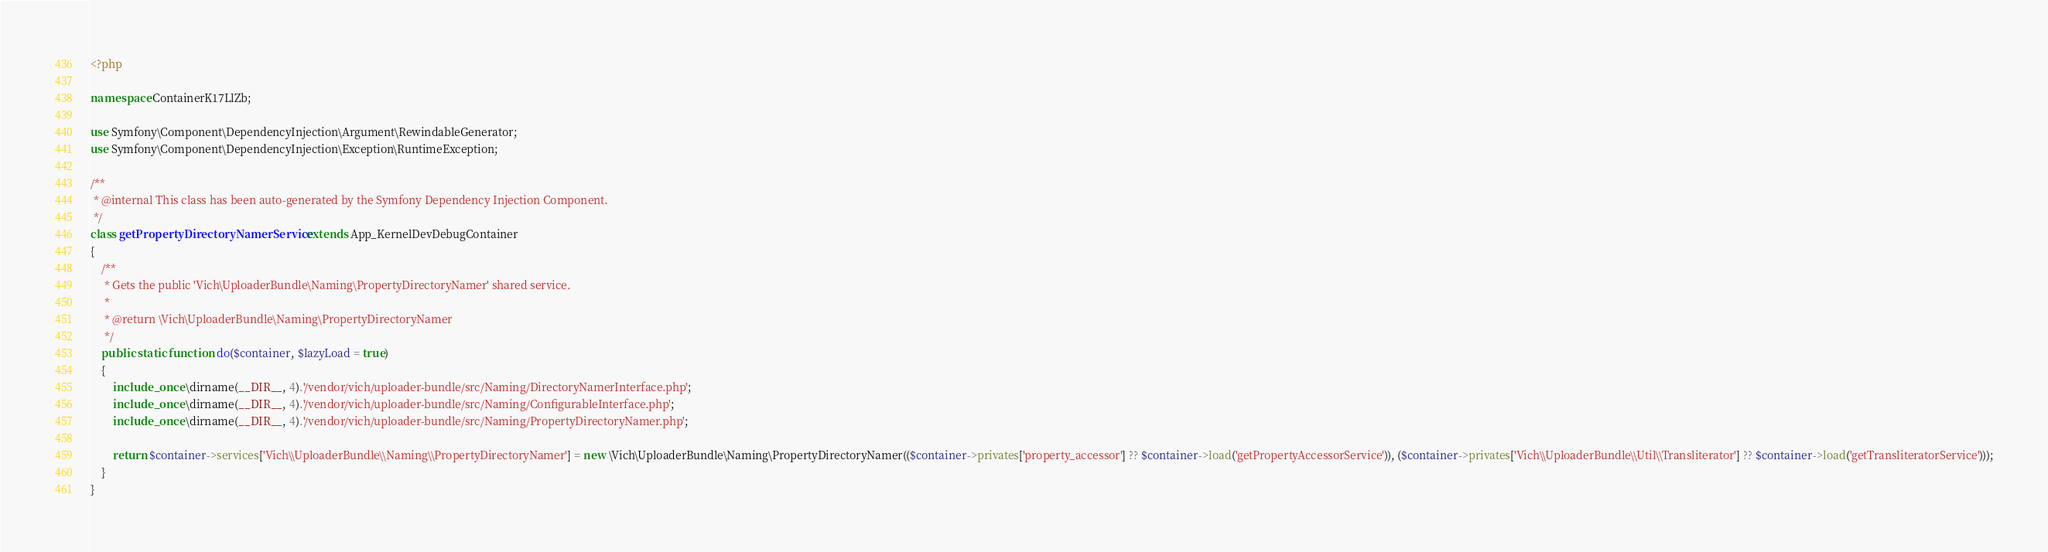<code> <loc_0><loc_0><loc_500><loc_500><_PHP_><?php

namespace ContainerK17LlZb;

use Symfony\Component\DependencyInjection\Argument\RewindableGenerator;
use Symfony\Component\DependencyInjection\Exception\RuntimeException;

/**
 * @internal This class has been auto-generated by the Symfony Dependency Injection Component.
 */
class getPropertyDirectoryNamerService extends App_KernelDevDebugContainer
{
    /**
     * Gets the public 'Vich\UploaderBundle\Naming\PropertyDirectoryNamer' shared service.
     *
     * @return \Vich\UploaderBundle\Naming\PropertyDirectoryNamer
     */
    public static function do($container, $lazyLoad = true)
    {
        include_once \dirname(__DIR__, 4).'/vendor/vich/uploader-bundle/src/Naming/DirectoryNamerInterface.php';
        include_once \dirname(__DIR__, 4).'/vendor/vich/uploader-bundle/src/Naming/ConfigurableInterface.php';
        include_once \dirname(__DIR__, 4).'/vendor/vich/uploader-bundle/src/Naming/PropertyDirectoryNamer.php';

        return $container->services['Vich\\UploaderBundle\\Naming\\PropertyDirectoryNamer'] = new \Vich\UploaderBundle\Naming\PropertyDirectoryNamer(($container->privates['property_accessor'] ?? $container->load('getPropertyAccessorService')), ($container->privates['Vich\\UploaderBundle\\Util\\Transliterator'] ?? $container->load('getTransliteratorService')));
    }
}
</code> 